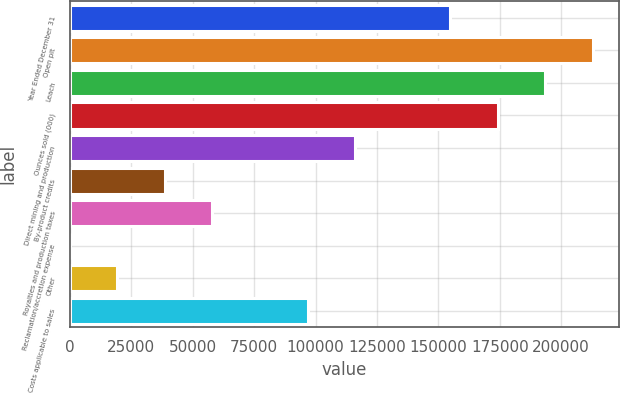Convert chart to OTSL. <chart><loc_0><loc_0><loc_500><loc_500><bar_chart><fcel>Year Ended December 31<fcel>Open pit<fcel>Leach<fcel>Ounces sold (000)<fcel>Direct mining and production<fcel>By-product credits<fcel>Royalties and production taxes<fcel>Reclamation/accretion expense<fcel>Other<fcel>Costs applicable to sales<nl><fcel>154852<fcel>212921<fcel>193565<fcel>174209<fcel>116140<fcel>38714.6<fcel>58070.9<fcel>2<fcel>19358.3<fcel>96783.5<nl></chart> 